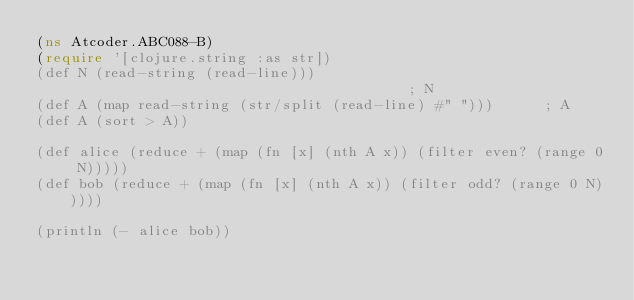Convert code to text. <code><loc_0><loc_0><loc_500><loc_500><_Clojure_>(ns Atcoder.ABC088-B)
(require '[clojure.string :as str])
(def N (read-string (read-line)))                                         ; N
(def A (map read-string (str/split (read-line) #" ")))      ; A
(def A (sort > A))

(def alice (reduce + (map (fn [x] (nth A x)) (filter even? (range 0 N)))))
(def bob (reduce + (map (fn [x] (nth A x)) (filter odd? (range 0 N)))))

(println (- alice bob))</code> 